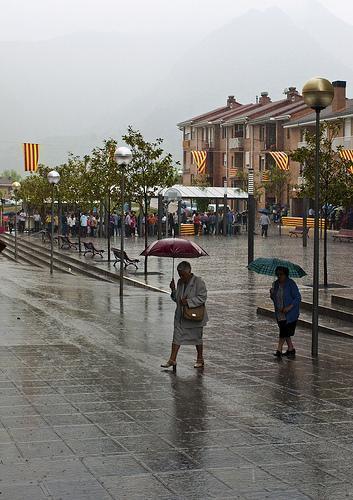How many hanging flags are there?
Give a very brief answer. 4. 